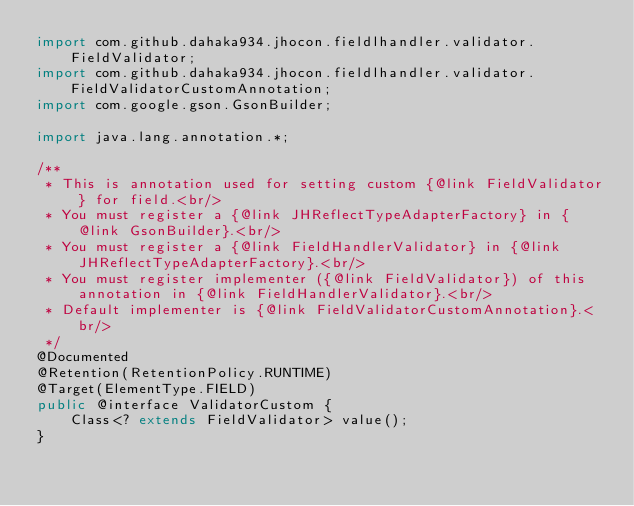<code> <loc_0><loc_0><loc_500><loc_500><_Java_>import com.github.dahaka934.jhocon.fieldlhandler.validator.FieldValidator;
import com.github.dahaka934.jhocon.fieldlhandler.validator.FieldValidatorCustomAnnotation;
import com.google.gson.GsonBuilder;

import java.lang.annotation.*;

/**
 * This is annotation used for setting custom {@link FieldValidator} for field.<br/>
 * You must register a {@link JHReflectTypeAdapterFactory} in {@link GsonBuilder}.<br/>
 * You must register a {@link FieldHandlerValidator} in {@link JHReflectTypeAdapterFactory}.<br/>
 * You must register implementer ({@link FieldValidator}) of this annotation in {@link FieldHandlerValidator}.<br/>
 * Default implementer is {@link FieldValidatorCustomAnnotation}.<br/>
 */
@Documented
@Retention(RetentionPolicy.RUNTIME)
@Target(ElementType.FIELD)
public @interface ValidatorCustom {
    Class<? extends FieldValidator> value();
}
</code> 